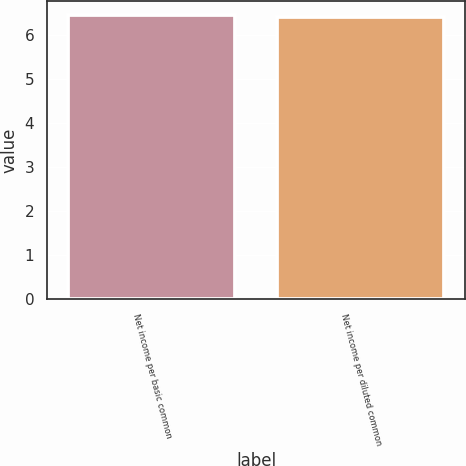<chart> <loc_0><loc_0><loc_500><loc_500><bar_chart><fcel>Net income per basic common<fcel>Net income per diluted common<nl><fcel>6.46<fcel>6.41<nl></chart> 